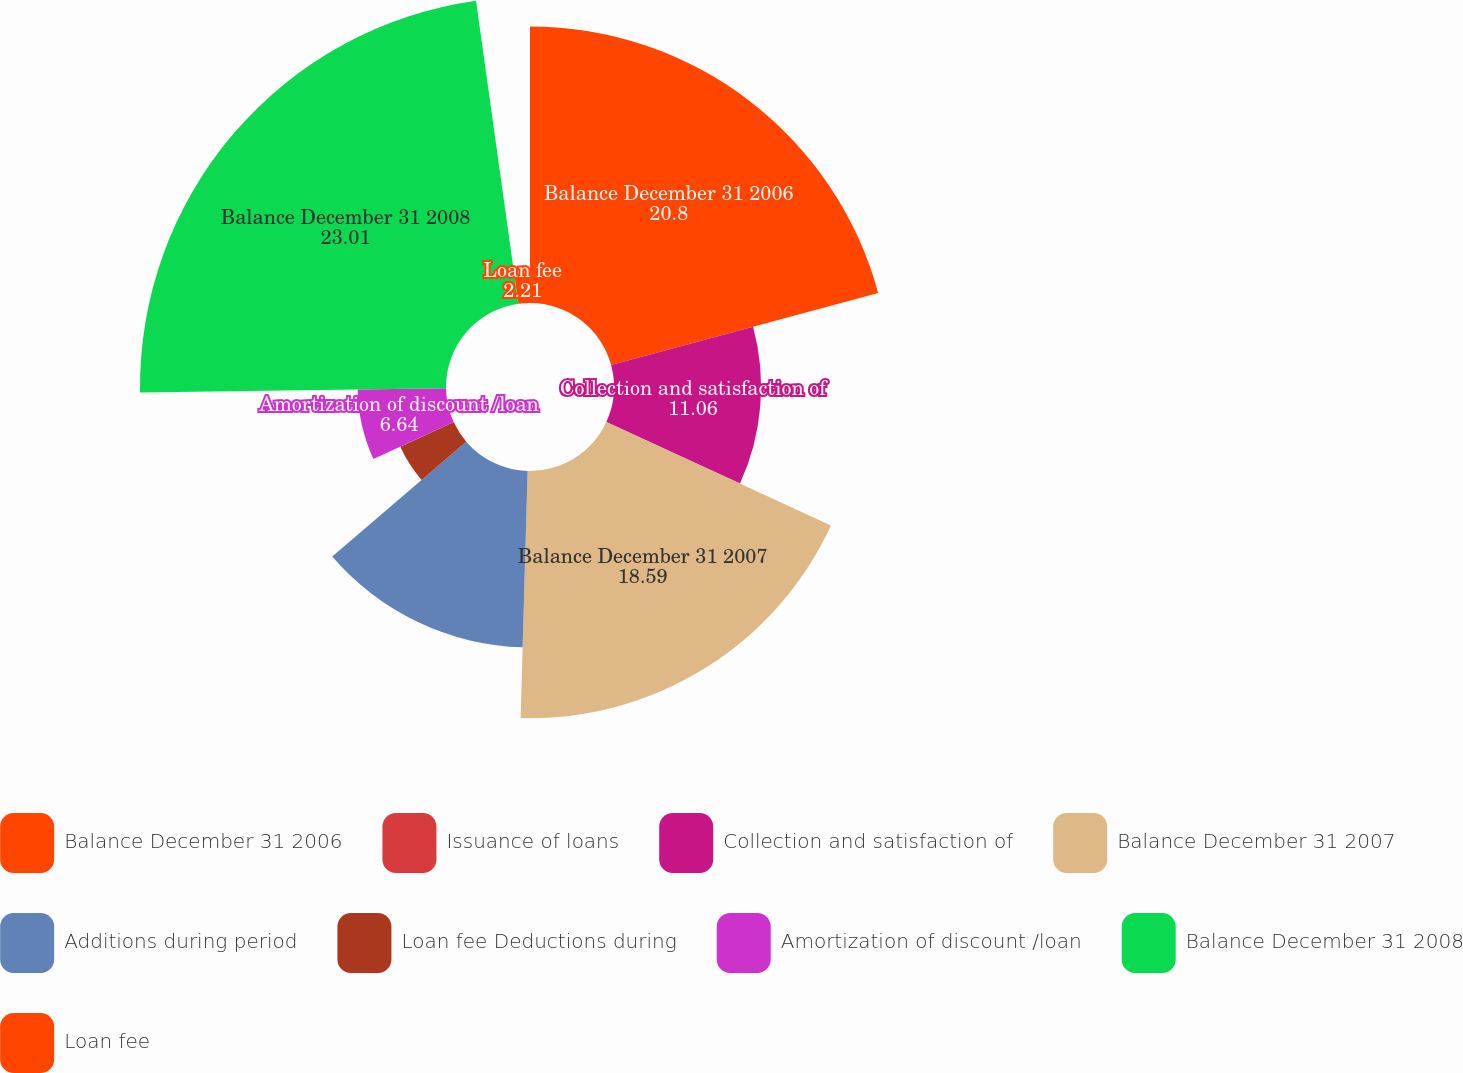<chart> <loc_0><loc_0><loc_500><loc_500><pie_chart><fcel>Balance December 31 2006<fcel>Issuance of loans<fcel>Collection and satisfaction of<fcel>Balance December 31 2007<fcel>Additions during period<fcel>Loan fee Deductions during<fcel>Amortization of discount /loan<fcel>Balance December 31 2008<fcel>Loan fee<nl><fcel>20.8%<fcel>0.0%<fcel>11.06%<fcel>18.59%<fcel>13.27%<fcel>4.42%<fcel>6.64%<fcel>23.01%<fcel>2.21%<nl></chart> 